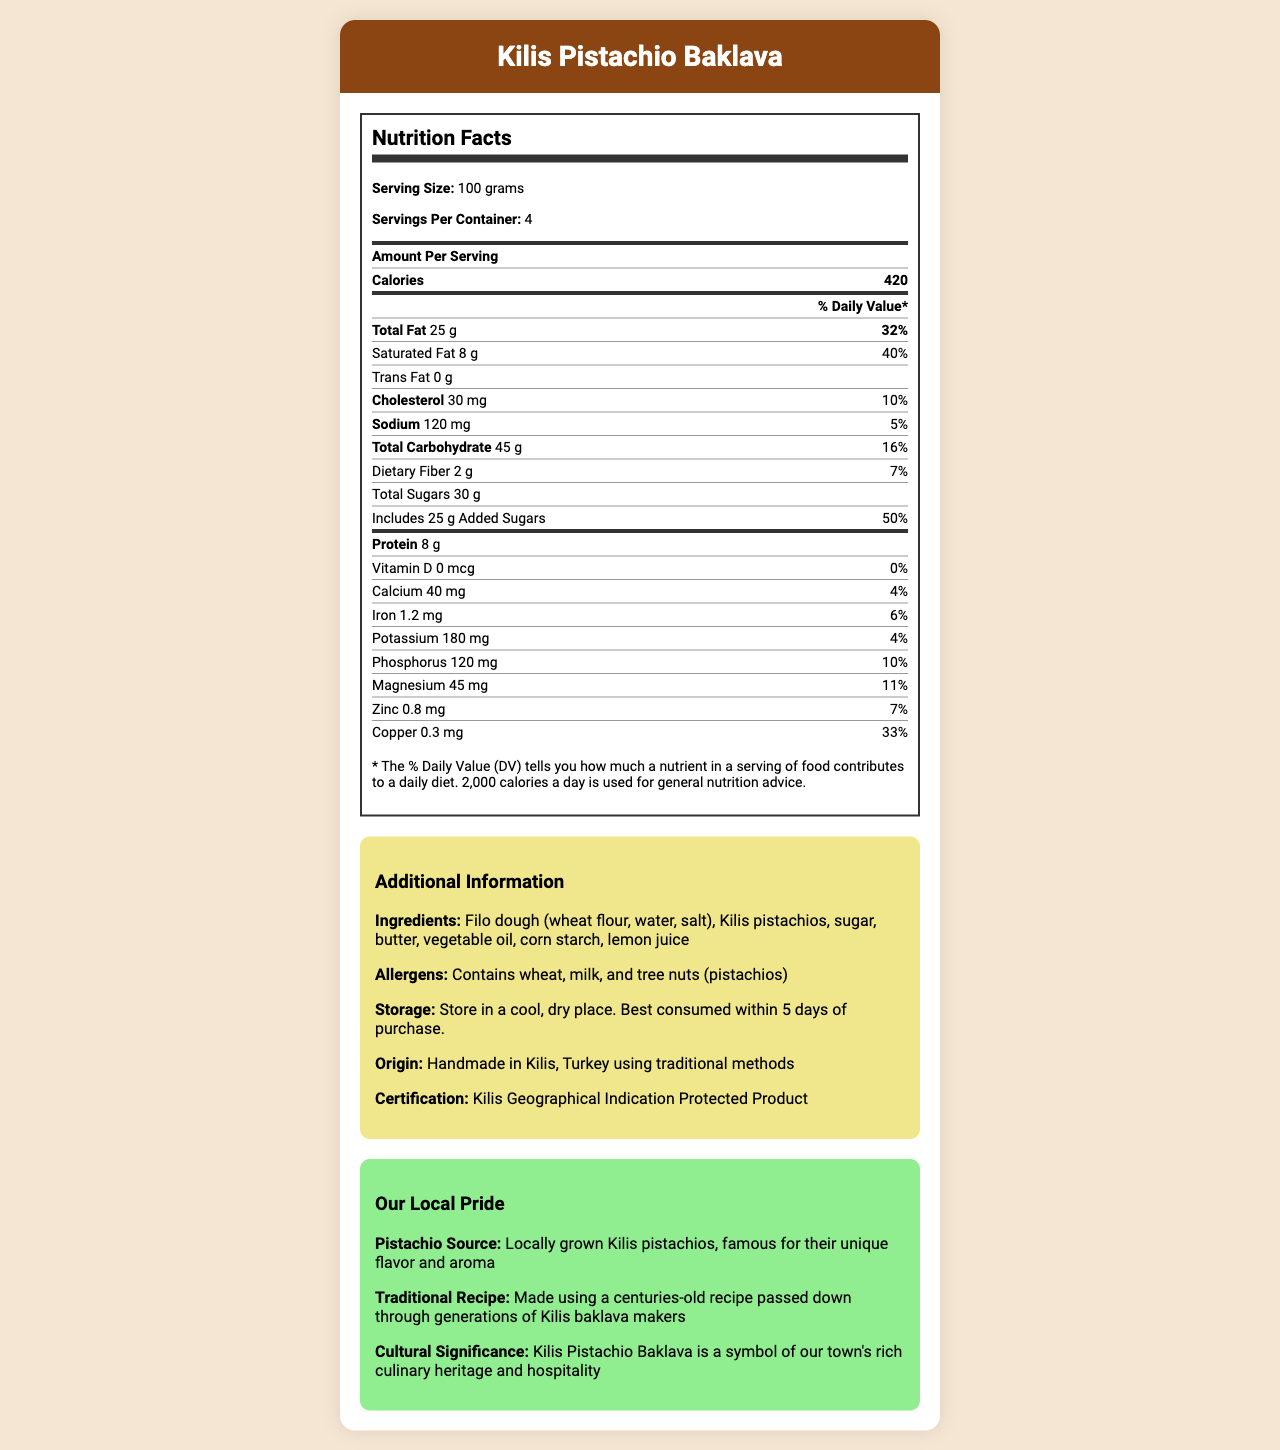what is the serving size for Kilis Pistachio Baklava? The serving size is mentioned at the top of the Nutrition Facts section as 100 grams.
Answer: 100 grams how many calories are there per serving? The document states the calories per serving as 420.
Answer: 420 what is the amount of total fat per serving? The Nutrition Facts section lists the total fat amount as 25 grams.
Answer: 25 g what is the percentage daily value of saturated fat? The document mentions that the saturated fat percentage daily value is 40%.
Answer: 40% does the baklava contain any trans fat? The Nutrition Facts section indicates 0 g for trans fat.
Answer: No what is the amount of sodium per serving? According to the document, there are 120 mg of sodium per serving.
Answer: 120 mg how much protein is in one serving? The Nutrition Facts section shows that there are 8 grams of protein per serving.
Answer: 8 g what is the serving size for Kilis Pistachio Baklava? A. 50 grams B. 100 grams C. 150 grams The serving size is mentioned as 100 grams.
Answer: B which ingredient is not contained in Kilis Pistachio Baklava? A. Wheat B. Milk C. Peanuts The allergens listed include wheat, milk, and tree nuts (pistachios), but not peanuts.
Answer: C does the document mention the origin of the pistachios used? The Local Pride section specifically mentions the pistachios are sourced locally from Kilis and are famous for their unique flavor and aroma.
Answer: Yes describe the overall document? The document contains various sections: Nutrition Facts, Additional Information (including ingredients, allergens, storage, and origin), and Local Pride. It represents the product's nutritional content and traditional significance while highlighting its cultural heritage.
Answer: The document provides detailed nutrition facts for Kilis Pistachio Baklava, including serving size, calories, and nutrient content. Additionally, it highlights the ingredients, allergens, storage instructions, and the cultural significance of the product with a focus on local pride and traditional methods. how much potassium is in each serving? The Nutrition Facts section indicates 180 mg of potassium per serving.
Answer: 180 mg what is the percentage daily value of copper? Copper's percent daily value is listed as 33% in the Nutrition Facts section.
Answer: 33% how many servings are in one container? The document specifies that there are 4 servings per container.
Answer: 4 which nutrient has the highest percent daily value? The percent daily value for added sugars is 50%, the highest among the listed nutrients.
Answer: Added Sugars what is the amount of dietary fiber per serving? The dietary fiber content per serving is listed as 2 grams.
Answer: 2 g is the document for a traditional or modern recipe? The Local Pride section clearly mentions that the baklava is made using a centuries-old recipe passed down through generations.
Answer: Traditional where are the pistachios sourced from? The Local Pride section specifies that the pistachios are locally grown in Kilis.
Answer: Locally grown in Kilis, Turkey who certified the product as a Kilis Geographical Indication Protected Product? The document mentions that the product is certified as a Kilis Geographical Indication Protected Product but does not specify who provided the certification.
Answer: Cannot be determined 